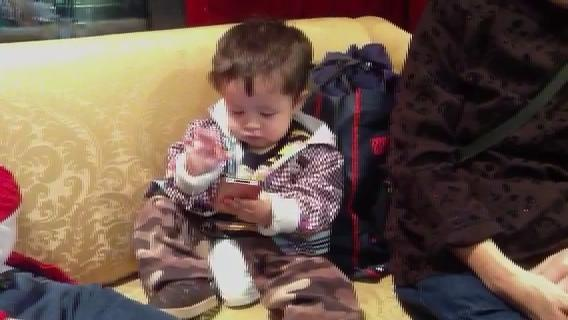What holiday is likely being celebrated here? Please explain your reasoning. christmas. The red and white to the left side of the image implies this, but it's difficult to tell. 